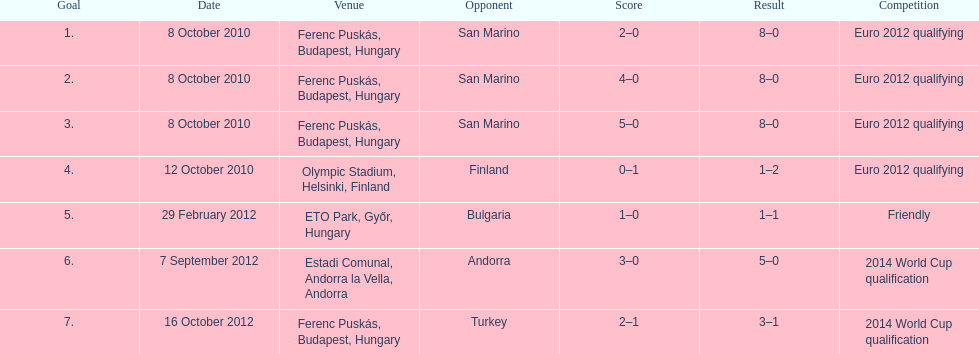What was the year when szalai netted his first goal internationally? 2010. 